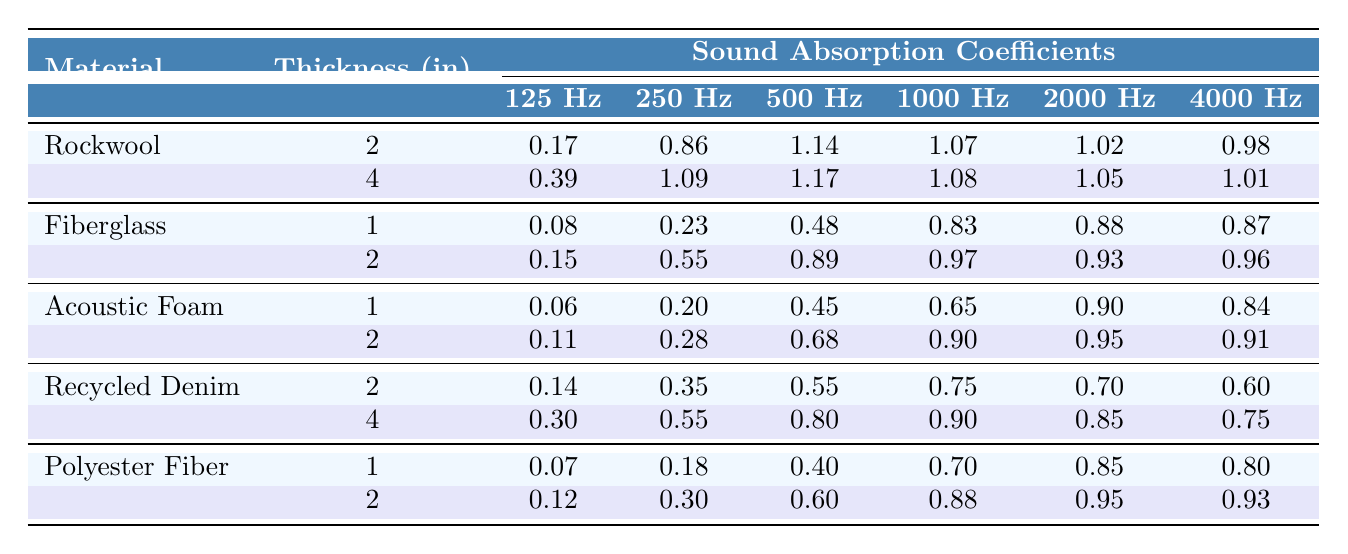What is the sound absorption coefficient of Rockwool at 1000 Hz with a thickness of 2 inches? From the table, under Rockwool for a thickness of 2 inches, the sound absorption coefficient at 1000 Hz is directly stated as 1.07.
Answer: 1.07 Which material has the highest sound absorption coefficient at 2000 Hz with a thickness of 4 inches? By examining the table, Rockwool at 4 inches has a coefficient of 1.05 at 2000 Hz, while Recycled Denim has 0.85. The highest value is clearly Rockwool at this thickness and frequency.
Answer: Rockwool What is the average sound absorption coefficient of Fiberglass at 500 Hz across the given thicknesses? For Fiberglass, at 1 inch the coefficient is 0.48 and at 2 inches it is 0.89. The average is (0.48 + 0.89) / 2 = 0.685.
Answer: 0.685 Is the sound absorption coefficient for Acoustic Foam greater than 0.9 at any frequency with a thickness of 2 inches? Checking the values for Acoustic Foam at a thickness of 2 inches reveals that the coefficients are 0.11 (125 Hz), 0.28 (250 Hz), 0.68 (500 Hz), 0.90 (1000 Hz), 0.95 (2000 Hz), and 0.91 (4000 Hz). Since it is greater than 0.9 at 2000 Hz and 4000 Hz, the answer is yes.
Answer: Yes What is the difference in sound absorption coefficient between Recycled Denim and Polyester Fiber at 250 Hz with a thickness of 2 inches? For Recycled Denim at 250 Hz (2 inches), the coefficient is 0.55. For Polyester Fiber at 250 Hz (2 inches), it is 0.30. The difference is 0.55 - 0.30 = 0.25.
Answer: 0.25 Which material shows the least absorption across all frequencies with a thickness of 1 inch? Upon reviewing the data for a thickness of 1 inch, Acoustic Foam has coefficients of 0.06 (125 Hz), 0.20 (250 Hz), 0.45 (500 Hz), 0.65 (1000 Hz), 0.90 (2000 Hz), and 0.84 (4000 Hz). Comparatively, Fiberglass has coefficients of 0.08 (125 Hz), 0.23 (250 Hz), 0.48 (500 Hz), 0.83 (1000 Hz), 0.88 (2000 Hz), and 0.87 (4000 Hz). Thus, Acoustic Foam demonstrates the least absorption at 125 Hz.
Answer: Acoustic Foam Which material consistently has the highest coefficients in the table irrespective of thickness? Analyzing the maximum values among all materials reveals that Rockwool has the highest coefficients across most frequencies compared to others, at both 2 and 4 inches.
Answer: Rockwool What is the trend observed in sound absorption coefficients as the frequency increases for Fiberglass at a thickness of 2 inches? For Fiberglass at 2 inches, the coefficients are 0.15 (125 Hz), 0.55 (250 Hz), 0.89 (500 Hz), 0.97 (1000 Hz), 0.93 (2000 Hz), and 0.96 (4000 Hz). It shows a general upward trend up to 1000 Hz, then slightly decreases at 2000 Hz and rises again at 4000 Hz.
Answer: General upward trend How do the coefficients at 4000 Hz compare between Acoustic Foam with 1 inch and Polyester Fiber with 1 inch? For Acoustic Foam at 1 inch, the coefficient is 0.84, and for Polyester Fiber at 1 inch, it is 0.80. The coefficient for Acoustic Foam is higher by 0.04.
Answer: Acoustic Foam is higher by 0.04 What is the sound absorption coefficient of Recycled Denim at 125 Hz with a thickness of 4 inches? The table shows that for Recycled Denim at a 4-inch thickness, the absorption coefficient at 125 Hz is 0.30.
Answer: 0.30 